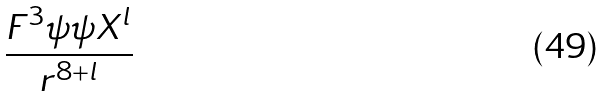Convert formula to latex. <formula><loc_0><loc_0><loc_500><loc_500>\frac { F ^ { 3 } \psi \psi X ^ { l } } { r ^ { 8 + l } }</formula> 